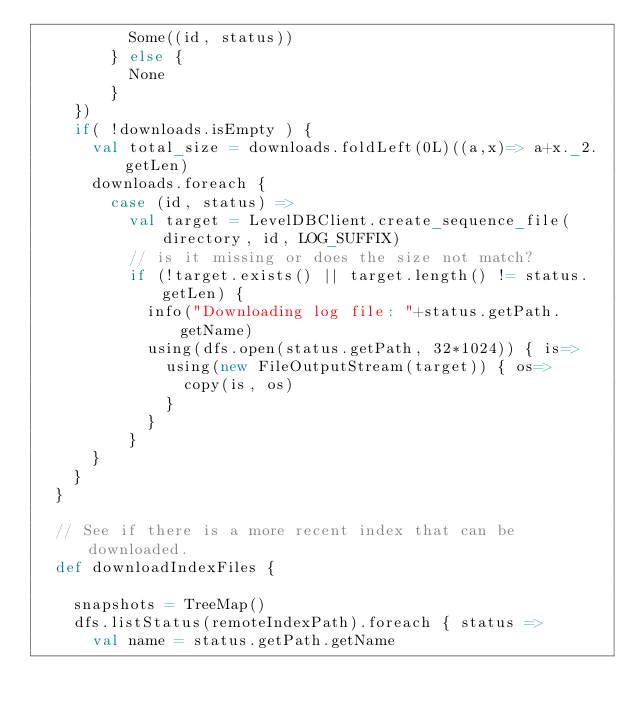Convert code to text. <code><loc_0><loc_0><loc_500><loc_500><_Scala_>          Some((id, status))
        } else {
          None
        }
    })
    if( !downloads.isEmpty ) {
      val total_size = downloads.foldLeft(0L)((a,x)=> a+x._2.getLen)
      downloads.foreach {
        case (id, status) =>
          val target = LevelDBClient.create_sequence_file(directory, id, LOG_SUFFIX)
          // is it missing or does the size not match?
          if (!target.exists() || target.length() != status.getLen) {
            info("Downloading log file: "+status.getPath.getName)
            using(dfs.open(status.getPath, 32*1024)) { is=>
              using(new FileOutputStream(target)) { os=>
                copy(is, os)
              }
            }
          }
      }
    }
  }

  // See if there is a more recent index that can be downloaded.
  def downloadIndexFiles {

    snapshots = TreeMap()
    dfs.listStatus(remoteIndexPath).foreach { status =>
      val name = status.getPath.getName</code> 